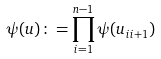Convert formula to latex. <formula><loc_0><loc_0><loc_500><loc_500>\psi ( u ) \colon = \prod _ { i = 1 } ^ { n - 1 } \psi ( u _ { i i + 1 } )</formula> 